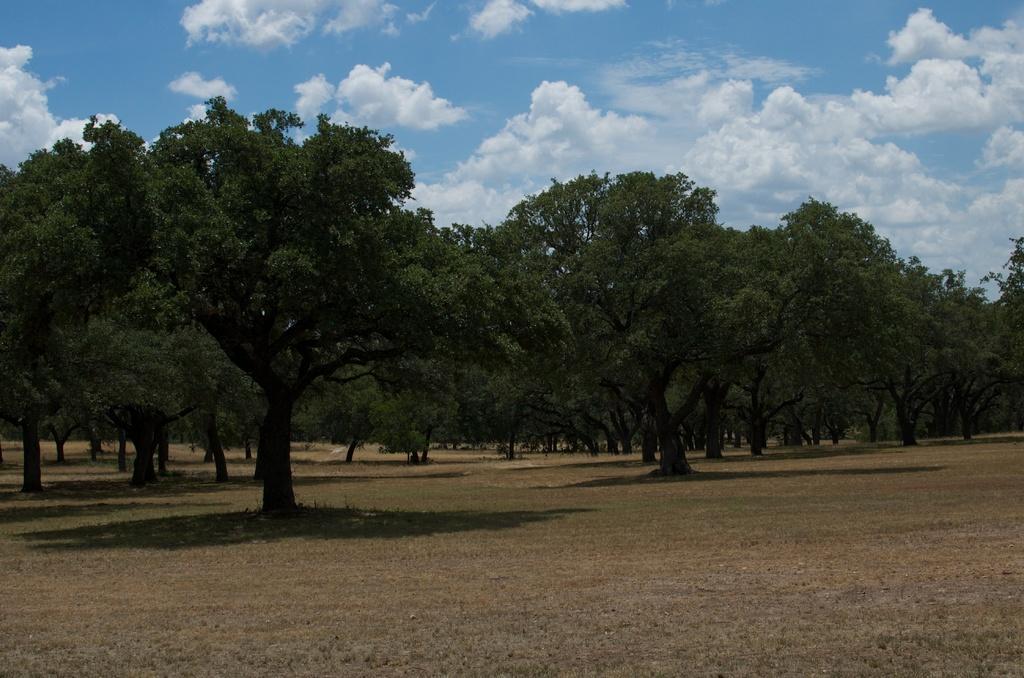Describe this image in one or two sentences. In this image, I can see the trees. In the background, there is the sky. 